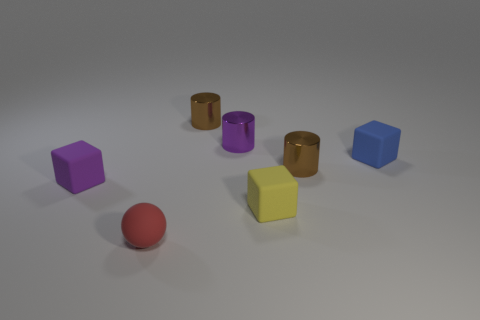Is there anything else that is the same shape as the red matte thing?
Give a very brief answer. No. Are there more small shiny cylinders than things?
Provide a short and direct response. No. How many matte objects are both left of the tiny yellow thing and behind the tiny purple matte block?
Your response must be concise. 0. How many tiny cylinders are behind the purple cube left of the red rubber sphere?
Ensure brevity in your answer.  3. What number of tiny cylinders are there?
Provide a succinct answer. 3. How many blue objects have the same material as the small ball?
Keep it short and to the point. 1. Are there the same number of blue matte things that are to the right of the blue matte thing and cyan cylinders?
Ensure brevity in your answer.  Yes. How many other objects are there of the same size as the yellow object?
Provide a short and direct response. 6. How many other objects are the same shape as the tiny yellow matte object?
Keep it short and to the point. 2. Is the blue thing the same size as the yellow thing?
Ensure brevity in your answer.  Yes. 